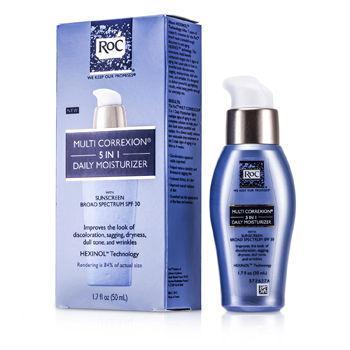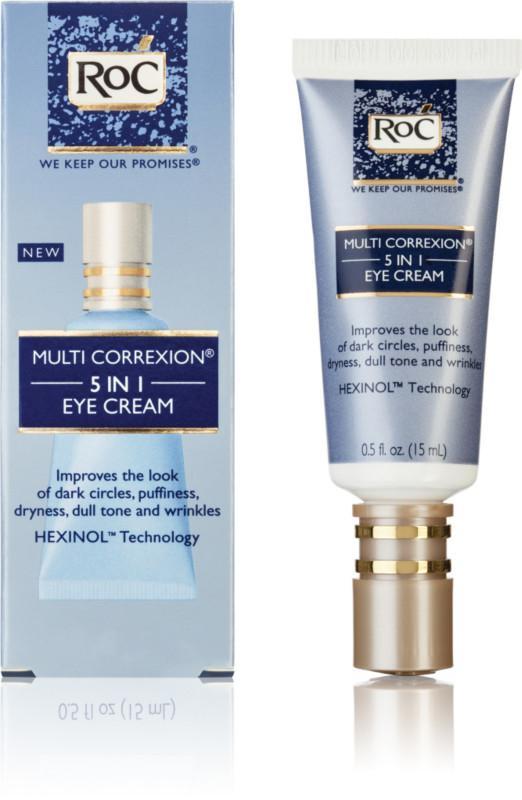The first image is the image on the left, the second image is the image on the right. Examine the images to the left and right. Is the description "Each image depicts one skincare product next to its box." accurate? Answer yes or no. Yes. The first image is the image on the left, the second image is the image on the right. Assess this claim about the two images: "In each image, exactly one product is beside its box.". Correct or not? Answer yes or no. Yes. 